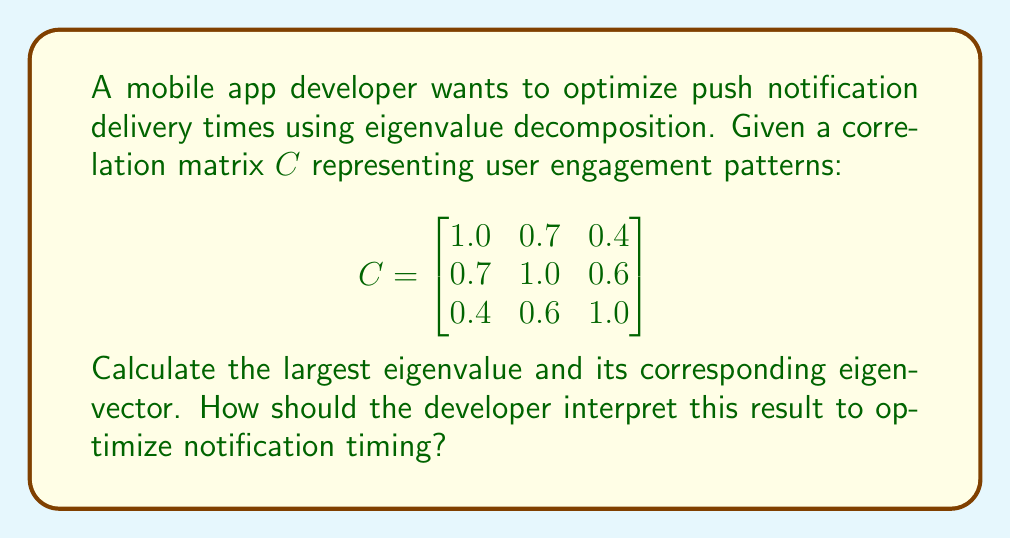Give your solution to this math problem. 1) To find eigenvalues, solve the characteristic equation:
   $\det(C - \lambda I) = 0$

2) Expanding the determinant:
   $$(1-\lambda)(1-\lambda)(1-\lambda) - 0.7^2(1-\lambda) - 0.4^2(1-\lambda) - 0.6^2(1-\lambda) + 2(0.7)(0.4)(0.6) = 0$$

3) Simplifying:
   $$-\lambda^3 + 3\lambda^2 - 2.51\lambda + 0.468 = 0$$

4) Solving this cubic equation (using a calculator or computer algebra system) yields:
   $$\lambda_1 \approx 2.1736, \lambda_2 \approx 0.5590, \lambda_3 \approx 0.2674$$

5) The largest eigenvalue is $\lambda_1 \approx 2.1736$

6) To find the corresponding eigenvector $v$, solve:
   $(C - \lambda_1 I)v = 0$

7) Substituting and solving (again, using computational tools):
   $$v \approx [0.5657, 0.6124, 0.5520]^T$$

8) Interpretation: The largest eigenvalue (2.1736) represents the direction of maximum variance in the data. The corresponding eigenvector [0.5657, 0.6124, 0.5520] suggests the optimal weighting for notification timing across three time periods (e.g., morning, afternoon, evening). The second component (0.6124) has the highest weight, indicating that the second time period might be the most effective for sending notifications.
Answer: Largest eigenvalue: 2.1736; Eigenvector: [0.5657, 0.6124, 0.5520]. Optimize notifications by focusing on the second time period. 